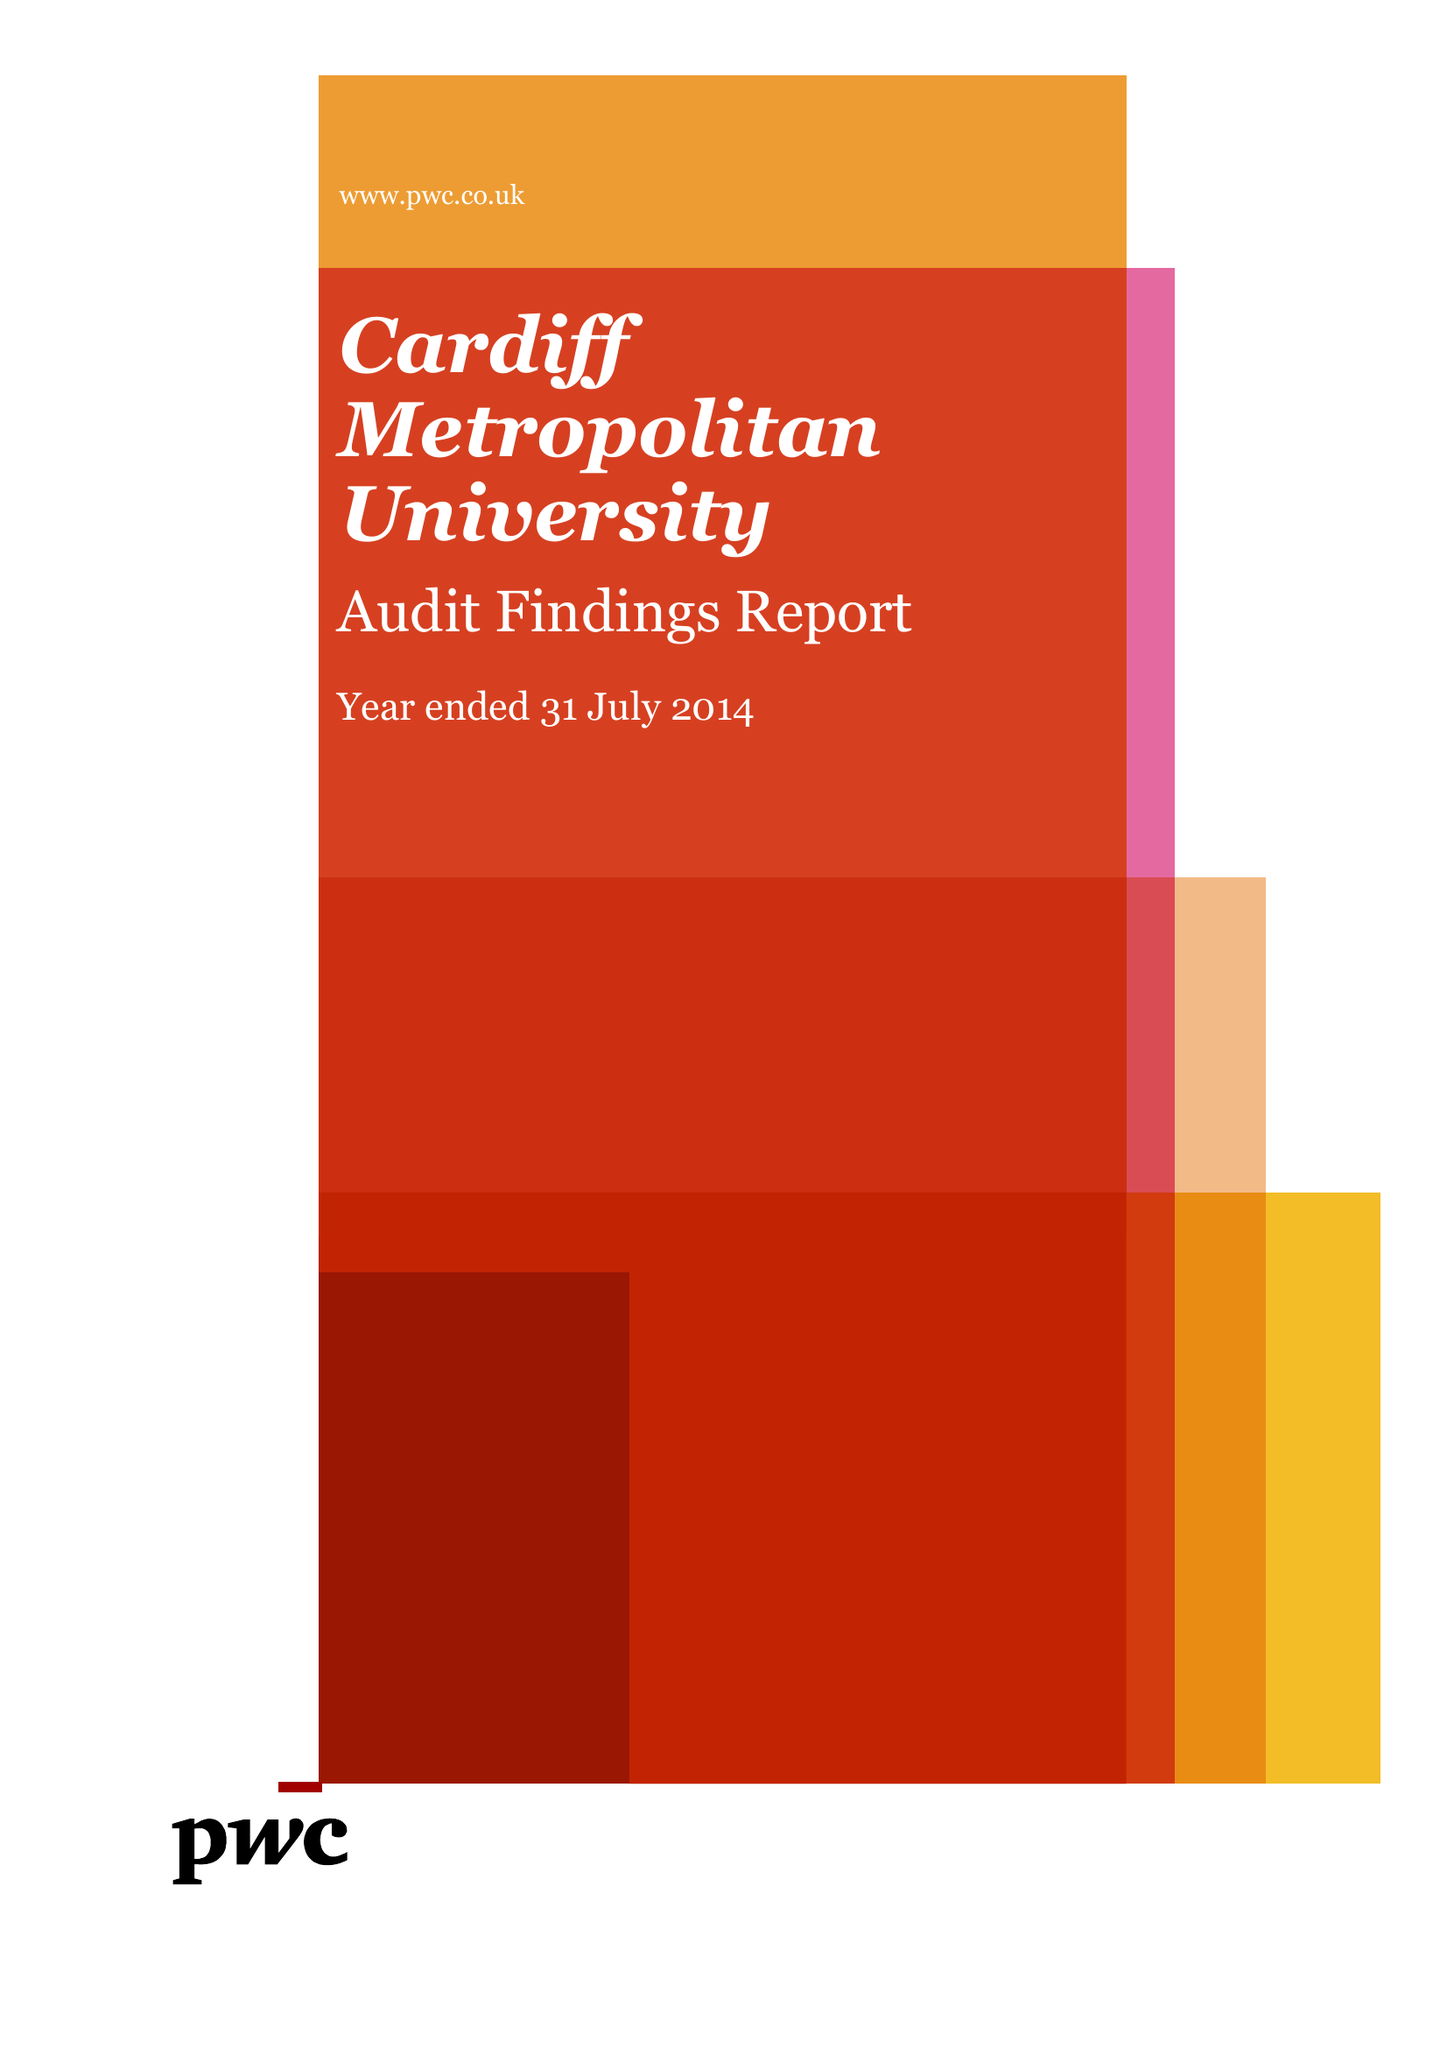What is the value for the spending_annually_in_british_pounds?
Answer the question using a single word or phrase. 85476000.00 